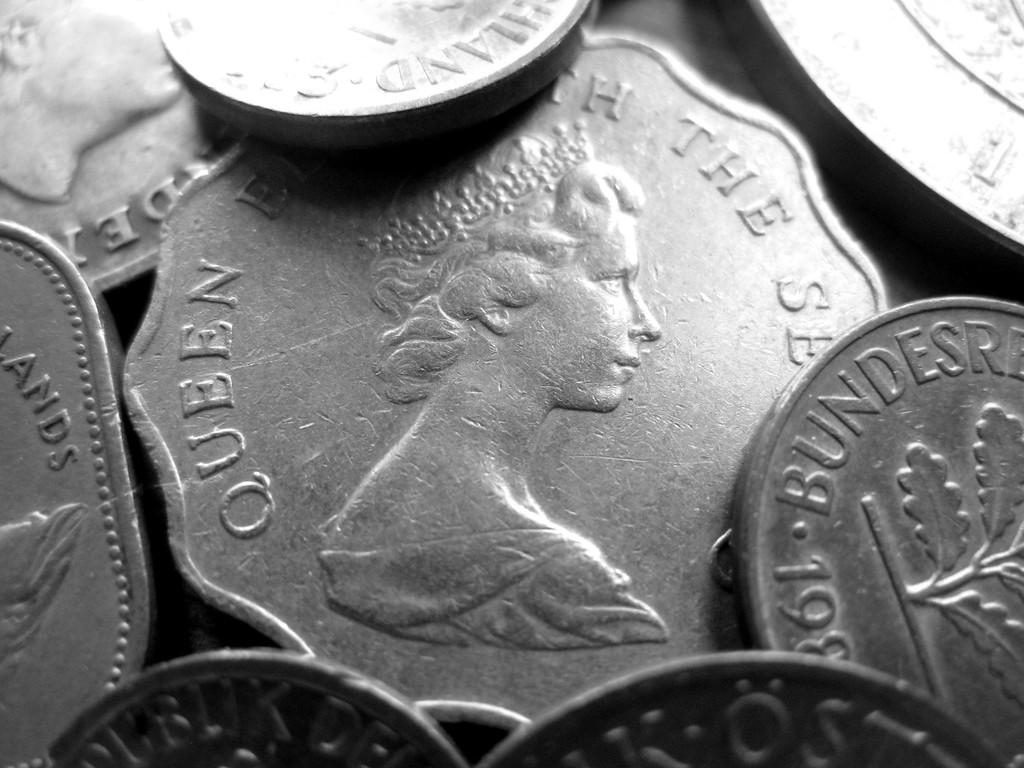Who is the lady on this coin?
Your answer should be compact. Queen elizabeth. What word is on the upper right side of the center coin?
Give a very brief answer. The. 